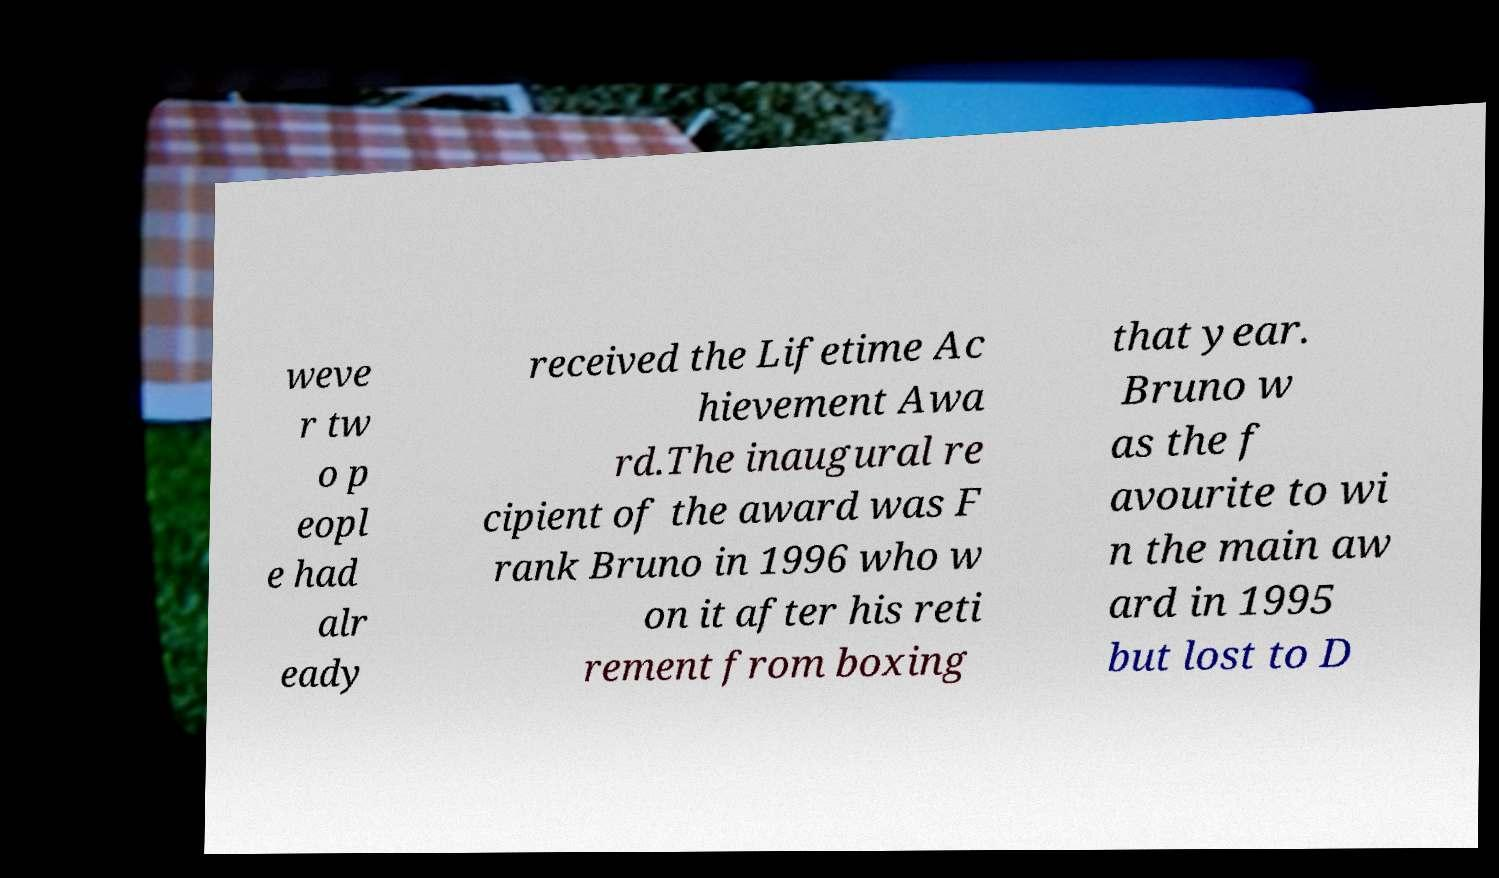Can you read and provide the text displayed in the image?This photo seems to have some interesting text. Can you extract and type it out for me? weve r tw o p eopl e had alr eady received the Lifetime Ac hievement Awa rd.The inaugural re cipient of the award was F rank Bruno in 1996 who w on it after his reti rement from boxing that year. Bruno w as the f avourite to wi n the main aw ard in 1995 but lost to D 